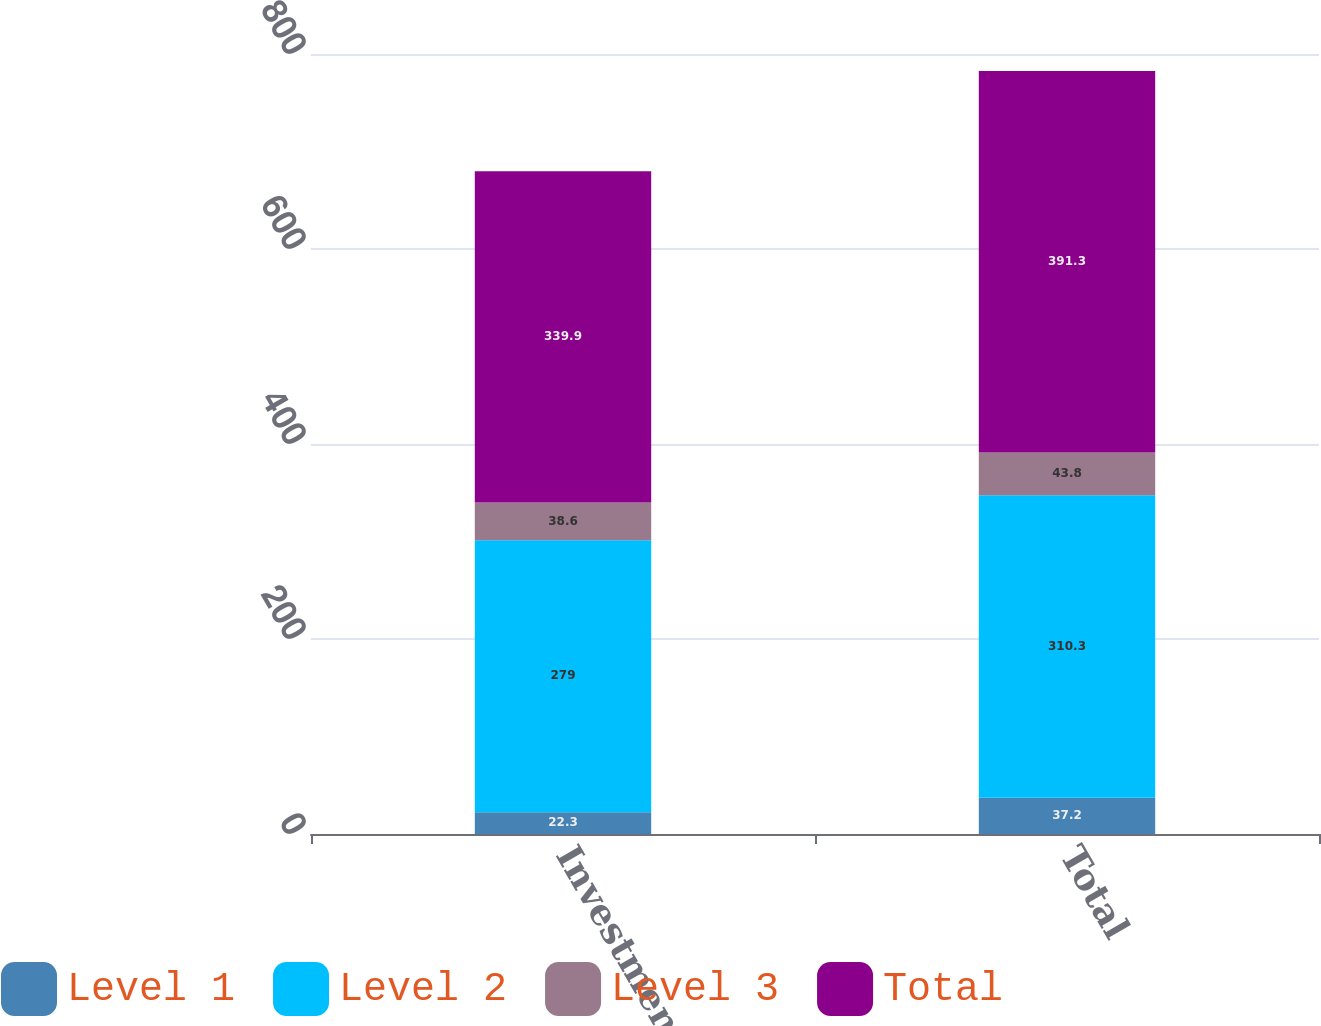Convert chart to OTSL. <chart><loc_0><loc_0><loc_500><loc_500><stacked_bar_chart><ecel><fcel>Investment funds<fcel>Total<nl><fcel>Level 1<fcel>22.3<fcel>37.2<nl><fcel>Level 2<fcel>279<fcel>310.3<nl><fcel>Level 3<fcel>38.6<fcel>43.8<nl><fcel>Total<fcel>339.9<fcel>391.3<nl></chart> 